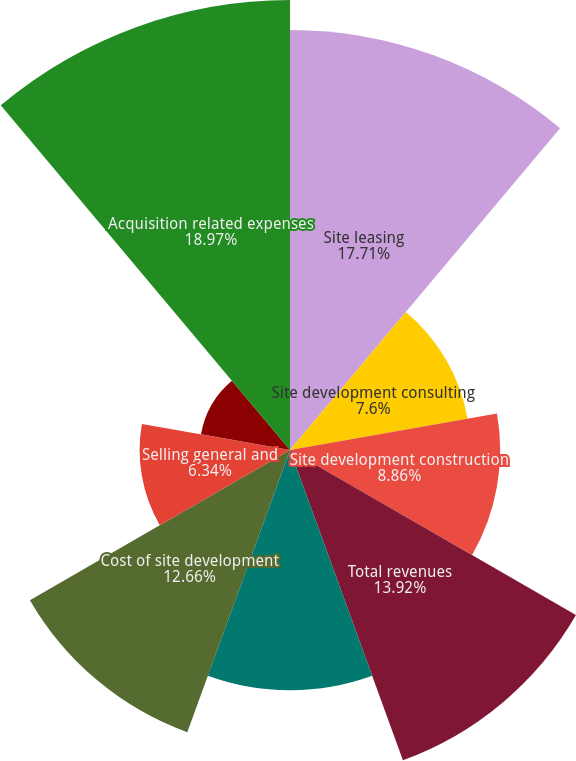<chart> <loc_0><loc_0><loc_500><loc_500><pie_chart><fcel>Site leasing<fcel>Site development consulting<fcel>Site development construction<fcel>Total revenues<fcel>Cost of site leasing<fcel>Cost of site development<fcel>Selling general and<fcel>Asset impairment<fcel>Acquisition related expenses<nl><fcel>17.71%<fcel>7.6%<fcel>8.86%<fcel>13.92%<fcel>10.13%<fcel>12.66%<fcel>6.34%<fcel>3.81%<fcel>18.97%<nl></chart> 